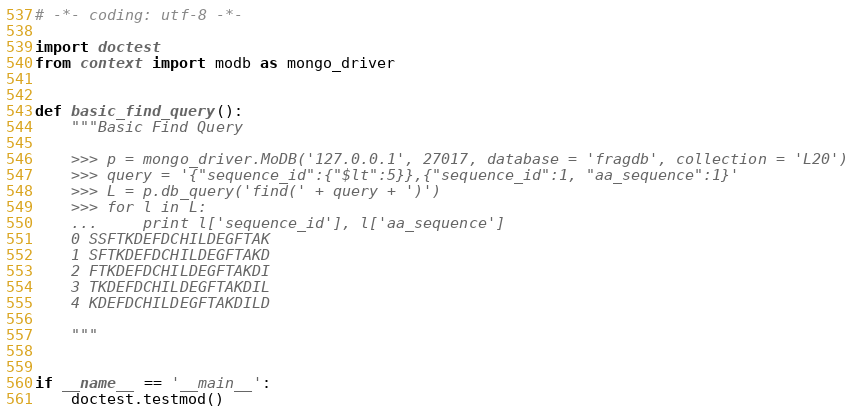Convert code to text. <code><loc_0><loc_0><loc_500><loc_500><_Python_># -*- coding: utf-8 -*-

import doctest
from context import modb as mongo_driver
	

def basic_find_query():
	"""Basic Find Query
	
	>>> p = mongo_driver.MoDB('127.0.0.1', 27017, database = 'fragdb', collection = 'L20')
	>>> query = '{"sequence_id":{"$lt":5}},{"sequence_id":1, "aa_sequence":1}'
	>>> L = p.db_query('find(' + query + ')')
	>>> for l in L:
	... 	print l['sequence_id'], l['aa_sequence']
	0 SSFTKDEFDCHILDEGFTAK
	1 SFTKDEFDCHILDEGFTAKD
	2 FTKDEFDCHILDEGFTAKDI
	3 TKDEFDCHILDEGFTAKDIL
	4 KDEFDCHILDEGFTAKDILD
	
	"""


if __name__ == '__main__':
	doctest.testmod()
</code> 